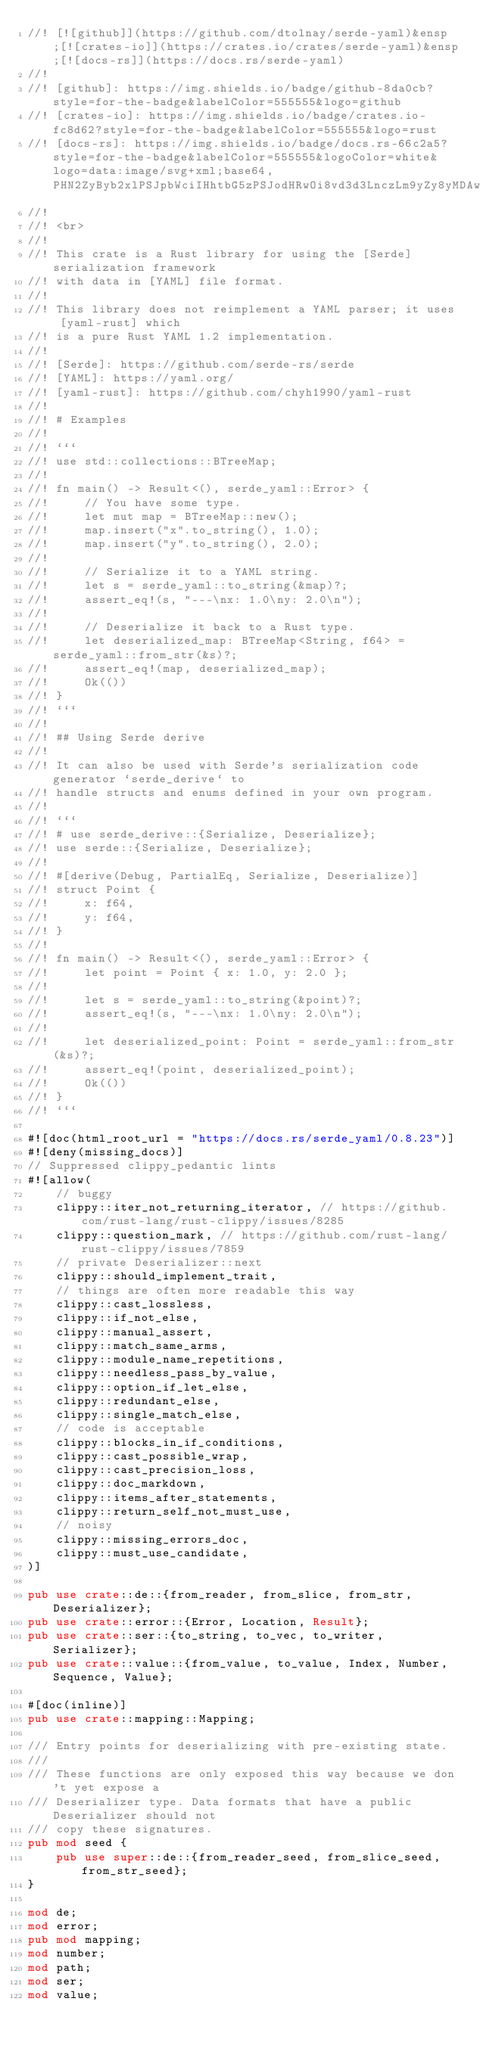Convert code to text. <code><loc_0><loc_0><loc_500><loc_500><_Rust_>//! [![github]](https://github.com/dtolnay/serde-yaml)&ensp;[![crates-io]](https://crates.io/crates/serde-yaml)&ensp;[![docs-rs]](https://docs.rs/serde-yaml)
//!
//! [github]: https://img.shields.io/badge/github-8da0cb?style=for-the-badge&labelColor=555555&logo=github
//! [crates-io]: https://img.shields.io/badge/crates.io-fc8d62?style=for-the-badge&labelColor=555555&logo=rust
//! [docs-rs]: https://img.shields.io/badge/docs.rs-66c2a5?style=for-the-badge&labelColor=555555&logoColor=white&logo=data:image/svg+xml;base64,PHN2ZyByb2xlPSJpbWciIHhtbG5zPSJodHRwOi8vd3d3LnczLm9yZy8yMDAwL3N2ZyIgdmlld0JveD0iMCAwIDUxMiA1MTIiPjxwYXRoIGZpbGw9IiNmNWY1ZjUiIGQ9Ik00ODguNiAyNTAuMkwzOTIgMjE0VjEwNS41YzAtMTUtOS4zLTI4LjQtMjMuNC0zMy43bC0xMDAtMzcuNWMtOC4xLTMuMS0xNy4xLTMuMS0yNS4zIDBsLTEwMCAzNy41Yy0xNC4xIDUuMy0yMy40IDE4LjctMjMuNCAzMy43VjIxNGwtOTYuNiAzNi4yQzkuMyAyNTUuNSAwIDI2OC45IDAgMjgzLjlWMzk0YzAgMTMuNiA3LjcgMjYuMSAxOS45IDMyLjJsMTAwIDUwYzEwLjEgNS4xIDIyLjEgNS4xIDMyLjIgMGwxMDMuOS01MiAxMDMuOSA1MmMxMC4xIDUuMSAyMi4xIDUuMSAzMi4yIDBsMTAwLTUwYzEyLjItNi4xIDE5LjktMTguNiAxOS45LTMyLjJWMjgzLjljMC0xNS05LjMtMjguNC0yMy40LTMzLjd6TTM1OCAyMTQuOGwtODUgMzEuOXYtNjguMmw4NS0zN3Y3My4zek0xNTQgMTA0LjFsMTAyLTM4LjIgMTAyIDM4LjJ2LjZsLTEwMiA0MS40LTEwMi00MS40di0uNnptODQgMjkxLjFsLTg1IDQyLjV2LTc5LjFsODUtMzguOHY3NS40em0wLTExMmwtMTAyIDQxLjQtMTAyLTQxLjR2LS42bDEwMi0zOC4yIDEwMiAzOC4ydi42em0yNDAgMTEybC04NSA0Mi41di03OS4xbDg1LTM4Ljh2NzUuNHptMC0xMTJsLTEwMiA0MS40LTEwMi00MS40di0uNmwxMDItMzguMiAxMDIgMzguMnYuNnoiPjwvcGF0aD48L3N2Zz4K
//!
//! <br>
//!
//! This crate is a Rust library for using the [Serde] serialization framework
//! with data in [YAML] file format.
//!
//! This library does not reimplement a YAML parser; it uses [yaml-rust] which
//! is a pure Rust YAML 1.2 implementation.
//!
//! [Serde]: https://github.com/serde-rs/serde
//! [YAML]: https://yaml.org/
//! [yaml-rust]: https://github.com/chyh1990/yaml-rust
//!
//! # Examples
//!
//! ```
//! use std::collections::BTreeMap;
//!
//! fn main() -> Result<(), serde_yaml::Error> {
//!     // You have some type.
//!     let mut map = BTreeMap::new();
//!     map.insert("x".to_string(), 1.0);
//!     map.insert("y".to_string(), 2.0);
//!
//!     // Serialize it to a YAML string.
//!     let s = serde_yaml::to_string(&map)?;
//!     assert_eq!(s, "---\nx: 1.0\ny: 2.0\n");
//!
//!     // Deserialize it back to a Rust type.
//!     let deserialized_map: BTreeMap<String, f64> = serde_yaml::from_str(&s)?;
//!     assert_eq!(map, deserialized_map);
//!     Ok(())
//! }
//! ```
//!
//! ## Using Serde derive
//!
//! It can also be used with Serde's serialization code generator `serde_derive` to
//! handle structs and enums defined in your own program.
//!
//! ```
//! # use serde_derive::{Serialize, Deserialize};
//! use serde::{Serialize, Deserialize};
//!
//! #[derive(Debug, PartialEq, Serialize, Deserialize)]
//! struct Point {
//!     x: f64,
//!     y: f64,
//! }
//!
//! fn main() -> Result<(), serde_yaml::Error> {
//!     let point = Point { x: 1.0, y: 2.0 };
//!
//!     let s = serde_yaml::to_string(&point)?;
//!     assert_eq!(s, "---\nx: 1.0\ny: 2.0\n");
//!
//!     let deserialized_point: Point = serde_yaml::from_str(&s)?;
//!     assert_eq!(point, deserialized_point);
//!     Ok(())
//! }
//! ```

#![doc(html_root_url = "https://docs.rs/serde_yaml/0.8.23")]
#![deny(missing_docs)]
// Suppressed clippy_pedantic lints
#![allow(
    // buggy
    clippy::iter_not_returning_iterator, // https://github.com/rust-lang/rust-clippy/issues/8285
    clippy::question_mark, // https://github.com/rust-lang/rust-clippy/issues/7859
    // private Deserializer::next
    clippy::should_implement_trait,
    // things are often more readable this way
    clippy::cast_lossless,
    clippy::if_not_else,
    clippy::manual_assert,
    clippy::match_same_arms,
    clippy::module_name_repetitions,
    clippy::needless_pass_by_value,
    clippy::option_if_let_else,
    clippy::redundant_else,
    clippy::single_match_else,
    // code is acceptable
    clippy::blocks_in_if_conditions,
    clippy::cast_possible_wrap,
    clippy::cast_precision_loss,
    clippy::doc_markdown,
    clippy::items_after_statements,
    clippy::return_self_not_must_use,
    // noisy
    clippy::missing_errors_doc,
    clippy::must_use_candidate,
)]

pub use crate::de::{from_reader, from_slice, from_str, Deserializer};
pub use crate::error::{Error, Location, Result};
pub use crate::ser::{to_string, to_vec, to_writer, Serializer};
pub use crate::value::{from_value, to_value, Index, Number, Sequence, Value};

#[doc(inline)]
pub use crate::mapping::Mapping;

/// Entry points for deserializing with pre-existing state.
///
/// These functions are only exposed this way because we don't yet expose a
/// Deserializer type. Data formats that have a public Deserializer should not
/// copy these signatures.
pub mod seed {
    pub use super::de::{from_reader_seed, from_slice_seed, from_str_seed};
}

mod de;
mod error;
pub mod mapping;
mod number;
mod path;
mod ser;
mod value;
</code> 